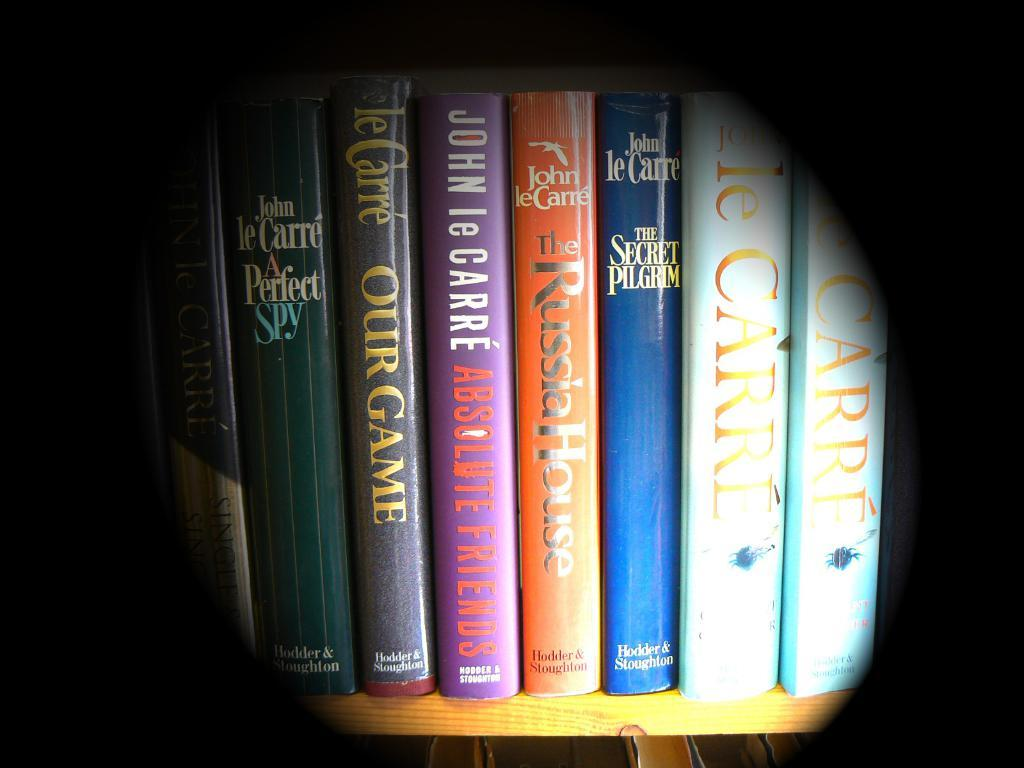<image>
Summarize the visual content of the image. A shelf of books are all by the author John leCarre. 